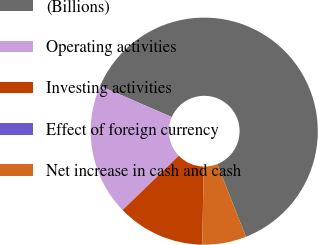Convert chart. <chart><loc_0><loc_0><loc_500><loc_500><pie_chart><fcel>(Billions)<fcel>Operating activities<fcel>Investing activities<fcel>Effect of foreign currency<fcel>Net increase in cash and cash<nl><fcel>62.49%<fcel>18.75%<fcel>12.5%<fcel>0.01%<fcel>6.25%<nl></chart> 